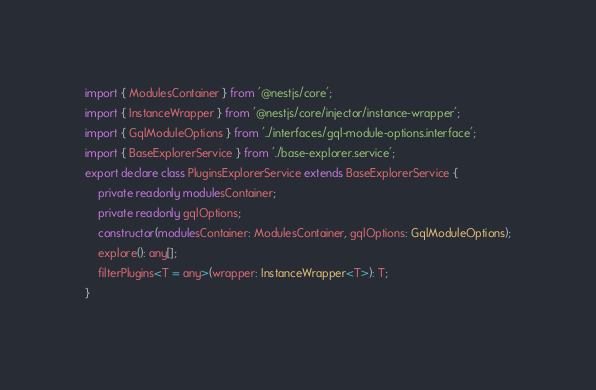Convert code to text. <code><loc_0><loc_0><loc_500><loc_500><_TypeScript_>import { ModulesContainer } from '@nestjs/core';
import { InstanceWrapper } from '@nestjs/core/injector/instance-wrapper';
import { GqlModuleOptions } from '../interfaces/gql-module-options.interface';
import { BaseExplorerService } from './base-explorer.service';
export declare class PluginsExplorerService extends BaseExplorerService {
    private readonly modulesContainer;
    private readonly gqlOptions;
    constructor(modulesContainer: ModulesContainer, gqlOptions: GqlModuleOptions);
    explore(): any[];
    filterPlugins<T = any>(wrapper: InstanceWrapper<T>): T;
}
</code> 